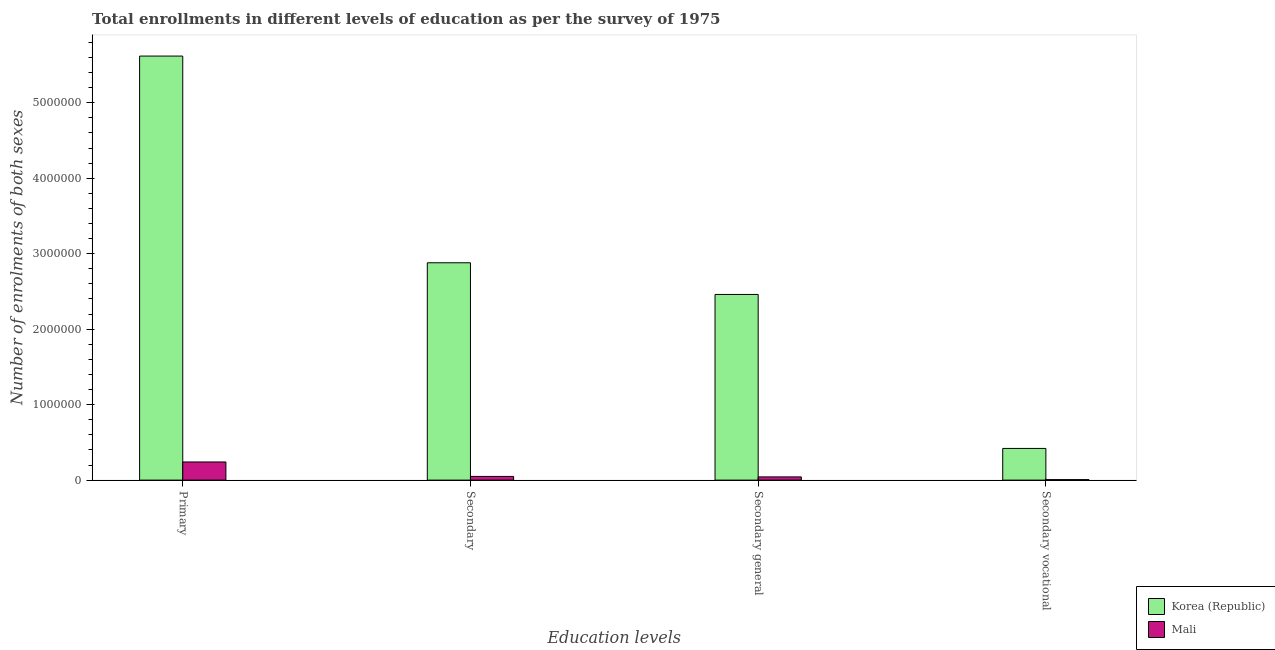Are the number of bars per tick equal to the number of legend labels?
Your answer should be compact. Yes. How many bars are there on the 2nd tick from the left?
Your answer should be compact. 2. What is the label of the 1st group of bars from the left?
Ensure brevity in your answer.  Primary. What is the number of enrolments in primary education in Mali?
Your answer should be compact. 2.41e+05. Across all countries, what is the maximum number of enrolments in secondary vocational education?
Your answer should be compact. 4.20e+05. Across all countries, what is the minimum number of enrolments in secondary general education?
Your answer should be very brief. 4.27e+04. In which country was the number of enrolments in primary education maximum?
Offer a terse response. Korea (Republic). In which country was the number of enrolments in secondary vocational education minimum?
Your answer should be compact. Mali. What is the total number of enrolments in secondary general education in the graph?
Provide a succinct answer. 2.50e+06. What is the difference between the number of enrolments in secondary vocational education in Korea (Republic) and that in Mali?
Give a very brief answer. 4.13e+05. What is the difference between the number of enrolments in secondary education in Korea (Republic) and the number of enrolments in primary education in Mali?
Give a very brief answer. 2.64e+06. What is the average number of enrolments in secondary education per country?
Offer a terse response. 1.46e+06. What is the difference between the number of enrolments in secondary general education and number of enrolments in secondary vocational education in Korea (Republic)?
Make the answer very short. 2.04e+06. In how many countries, is the number of enrolments in secondary education greater than 800000 ?
Make the answer very short. 1. What is the ratio of the number of enrolments in primary education in Korea (Republic) to that in Mali?
Make the answer very short. 23.36. Is the difference between the number of enrolments in secondary general education in Korea (Republic) and Mali greater than the difference between the number of enrolments in secondary education in Korea (Republic) and Mali?
Your answer should be compact. No. What is the difference between the highest and the second highest number of enrolments in secondary general education?
Offer a terse response. 2.42e+06. What is the difference between the highest and the lowest number of enrolments in primary education?
Offer a very short reply. 5.38e+06. Is it the case that in every country, the sum of the number of enrolments in secondary vocational education and number of enrolments in secondary education is greater than the sum of number of enrolments in secondary general education and number of enrolments in primary education?
Ensure brevity in your answer.  No. What does the 2nd bar from the right in Secondary vocational represents?
Offer a terse response. Korea (Republic). Is it the case that in every country, the sum of the number of enrolments in primary education and number of enrolments in secondary education is greater than the number of enrolments in secondary general education?
Make the answer very short. Yes. How many bars are there?
Provide a succinct answer. 8. Are all the bars in the graph horizontal?
Keep it short and to the point. No. How many countries are there in the graph?
Offer a terse response. 2. Are the values on the major ticks of Y-axis written in scientific E-notation?
Give a very brief answer. No. Does the graph contain grids?
Give a very brief answer. No. How many legend labels are there?
Provide a short and direct response. 2. How are the legend labels stacked?
Your answer should be very brief. Vertical. What is the title of the graph?
Offer a terse response. Total enrollments in different levels of education as per the survey of 1975. Does "European Union" appear as one of the legend labels in the graph?
Offer a very short reply. No. What is the label or title of the X-axis?
Keep it short and to the point. Education levels. What is the label or title of the Y-axis?
Keep it short and to the point. Number of enrolments of both sexes. What is the Number of enrolments of both sexes in Korea (Republic) in Primary?
Your answer should be very brief. 5.62e+06. What is the Number of enrolments of both sexes of Mali in Primary?
Ensure brevity in your answer.  2.41e+05. What is the Number of enrolments of both sexes in Korea (Republic) in Secondary?
Your answer should be very brief. 2.88e+06. What is the Number of enrolments of both sexes of Mali in Secondary?
Your answer should be compact. 4.90e+04. What is the Number of enrolments of both sexes of Korea (Republic) in Secondary general?
Provide a succinct answer. 2.46e+06. What is the Number of enrolments of both sexes of Mali in Secondary general?
Provide a short and direct response. 4.27e+04. What is the Number of enrolments of both sexes of Korea (Republic) in Secondary vocational?
Provide a short and direct response. 4.20e+05. What is the Number of enrolments of both sexes of Mali in Secondary vocational?
Provide a short and direct response. 6366. Across all Education levels, what is the maximum Number of enrolments of both sexes of Korea (Republic)?
Keep it short and to the point. 5.62e+06. Across all Education levels, what is the maximum Number of enrolments of both sexes in Mali?
Provide a short and direct response. 2.41e+05. Across all Education levels, what is the minimum Number of enrolments of both sexes of Korea (Republic)?
Offer a terse response. 4.20e+05. Across all Education levels, what is the minimum Number of enrolments of both sexes of Mali?
Your answer should be very brief. 6366. What is the total Number of enrolments of both sexes in Korea (Republic) in the graph?
Your response must be concise. 1.14e+07. What is the total Number of enrolments of both sexes of Mali in the graph?
Make the answer very short. 3.39e+05. What is the difference between the Number of enrolments of both sexes of Korea (Republic) in Primary and that in Secondary?
Offer a very short reply. 2.74e+06. What is the difference between the Number of enrolments of both sexes of Mali in Primary and that in Secondary?
Offer a very short reply. 1.91e+05. What is the difference between the Number of enrolments of both sexes of Korea (Republic) in Primary and that in Secondary general?
Provide a short and direct response. 3.16e+06. What is the difference between the Number of enrolments of both sexes of Mali in Primary and that in Secondary general?
Offer a terse response. 1.98e+05. What is the difference between the Number of enrolments of both sexes of Korea (Republic) in Primary and that in Secondary vocational?
Your response must be concise. 5.20e+06. What is the difference between the Number of enrolments of both sexes of Mali in Primary and that in Secondary vocational?
Your answer should be compact. 2.34e+05. What is the difference between the Number of enrolments of both sexes of Korea (Republic) in Secondary and that in Secondary general?
Give a very brief answer. 4.20e+05. What is the difference between the Number of enrolments of both sexes of Mali in Secondary and that in Secondary general?
Ensure brevity in your answer.  6366. What is the difference between the Number of enrolments of both sexes of Korea (Republic) in Secondary and that in Secondary vocational?
Make the answer very short. 2.46e+06. What is the difference between the Number of enrolments of both sexes of Mali in Secondary and that in Secondary vocational?
Your response must be concise. 4.27e+04. What is the difference between the Number of enrolments of both sexes of Korea (Republic) in Secondary general and that in Secondary vocational?
Provide a short and direct response. 2.04e+06. What is the difference between the Number of enrolments of both sexes in Mali in Secondary general and that in Secondary vocational?
Ensure brevity in your answer.  3.63e+04. What is the difference between the Number of enrolments of both sexes in Korea (Republic) in Primary and the Number of enrolments of both sexes in Mali in Secondary?
Provide a succinct answer. 5.57e+06. What is the difference between the Number of enrolments of both sexes in Korea (Republic) in Primary and the Number of enrolments of both sexes in Mali in Secondary general?
Ensure brevity in your answer.  5.58e+06. What is the difference between the Number of enrolments of both sexes in Korea (Republic) in Primary and the Number of enrolments of both sexes in Mali in Secondary vocational?
Offer a very short reply. 5.61e+06. What is the difference between the Number of enrolments of both sexes in Korea (Republic) in Secondary and the Number of enrolments of both sexes in Mali in Secondary general?
Offer a terse response. 2.84e+06. What is the difference between the Number of enrolments of both sexes in Korea (Republic) in Secondary and the Number of enrolments of both sexes in Mali in Secondary vocational?
Keep it short and to the point. 2.87e+06. What is the difference between the Number of enrolments of both sexes of Korea (Republic) in Secondary general and the Number of enrolments of both sexes of Mali in Secondary vocational?
Your answer should be very brief. 2.45e+06. What is the average Number of enrolments of both sexes of Korea (Republic) per Education levels?
Make the answer very short. 2.84e+06. What is the average Number of enrolments of both sexes of Mali per Education levels?
Provide a short and direct response. 8.46e+04. What is the difference between the Number of enrolments of both sexes of Korea (Republic) and Number of enrolments of both sexes of Mali in Primary?
Your answer should be compact. 5.38e+06. What is the difference between the Number of enrolments of both sexes in Korea (Republic) and Number of enrolments of both sexes in Mali in Secondary?
Your answer should be compact. 2.83e+06. What is the difference between the Number of enrolments of both sexes of Korea (Republic) and Number of enrolments of both sexes of Mali in Secondary general?
Your answer should be very brief. 2.42e+06. What is the difference between the Number of enrolments of both sexes in Korea (Republic) and Number of enrolments of both sexes in Mali in Secondary vocational?
Give a very brief answer. 4.13e+05. What is the ratio of the Number of enrolments of both sexes of Korea (Republic) in Primary to that in Secondary?
Your answer should be compact. 1.95. What is the ratio of the Number of enrolments of both sexes of Mali in Primary to that in Secondary?
Provide a short and direct response. 4.91. What is the ratio of the Number of enrolments of both sexes in Korea (Republic) in Primary to that in Secondary general?
Keep it short and to the point. 2.28. What is the ratio of the Number of enrolments of both sexes in Mali in Primary to that in Secondary general?
Give a very brief answer. 5.64. What is the ratio of the Number of enrolments of both sexes of Korea (Republic) in Primary to that in Secondary vocational?
Give a very brief answer. 13.38. What is the ratio of the Number of enrolments of both sexes in Mali in Primary to that in Secondary vocational?
Your response must be concise. 37.78. What is the ratio of the Number of enrolments of both sexes of Korea (Republic) in Secondary to that in Secondary general?
Ensure brevity in your answer.  1.17. What is the ratio of the Number of enrolments of both sexes of Mali in Secondary to that in Secondary general?
Your answer should be very brief. 1.15. What is the ratio of the Number of enrolments of both sexes in Korea (Republic) in Secondary to that in Secondary vocational?
Give a very brief answer. 6.86. What is the ratio of the Number of enrolments of both sexes in Mali in Secondary to that in Secondary vocational?
Your response must be concise. 7.7. What is the ratio of the Number of enrolments of both sexes in Korea (Republic) in Secondary general to that in Secondary vocational?
Keep it short and to the point. 5.86. What is the ratio of the Number of enrolments of both sexes in Mali in Secondary general to that in Secondary vocational?
Provide a succinct answer. 6.7. What is the difference between the highest and the second highest Number of enrolments of both sexes of Korea (Republic)?
Offer a terse response. 2.74e+06. What is the difference between the highest and the second highest Number of enrolments of both sexes of Mali?
Provide a short and direct response. 1.91e+05. What is the difference between the highest and the lowest Number of enrolments of both sexes of Korea (Republic)?
Offer a terse response. 5.20e+06. What is the difference between the highest and the lowest Number of enrolments of both sexes in Mali?
Give a very brief answer. 2.34e+05. 